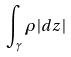<formula> <loc_0><loc_0><loc_500><loc_500>\int _ { \gamma } \rho | d z |</formula> 